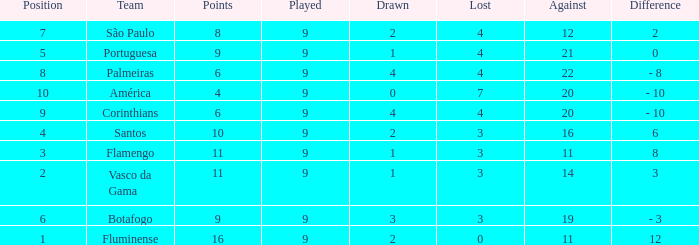Which average Played has a Drawn smaller than 1, and Points larger than 4? None. 